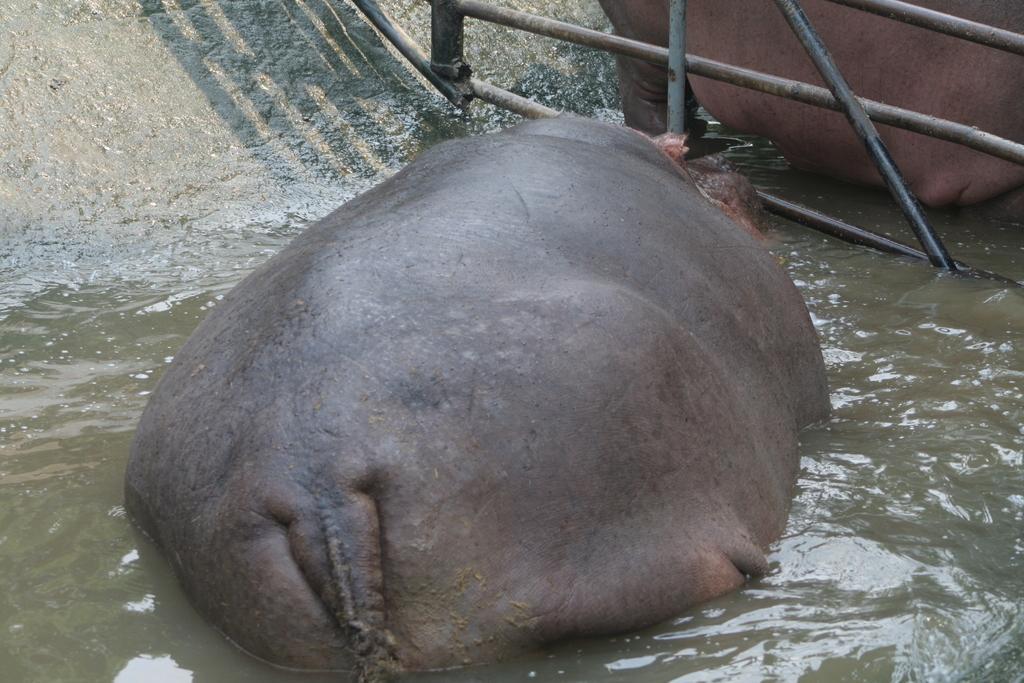Please provide a concise description of this image. In this picture I can see 2 animals, which are of black and brown color and I see that they're in water and on the top of this picture I can see the rods. On the left side of this picture I can see the stone surface. 